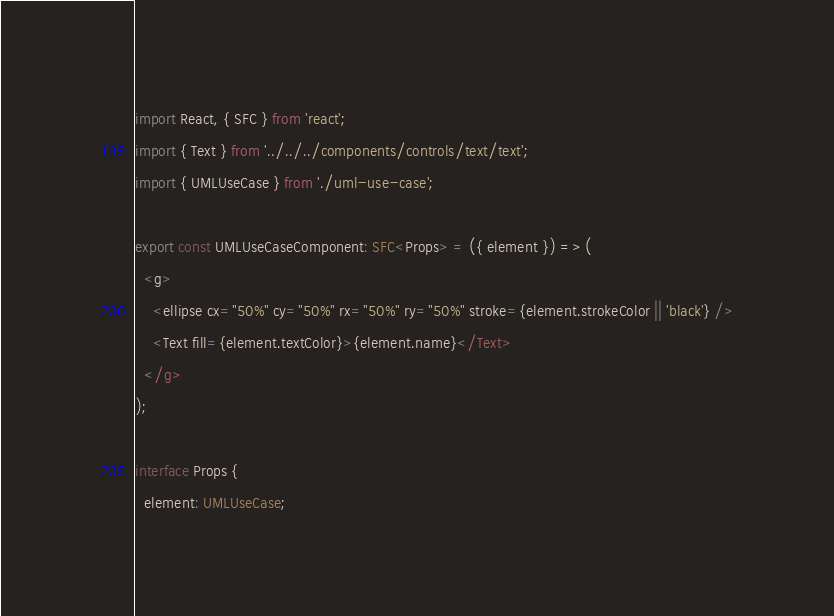Convert code to text. <code><loc_0><loc_0><loc_500><loc_500><_TypeScript_>import React, { SFC } from 'react';
import { Text } from '../../../components/controls/text/text';
import { UMLUseCase } from './uml-use-case';

export const UMLUseCaseComponent: SFC<Props> = ({ element }) => (
  <g>
    <ellipse cx="50%" cy="50%" rx="50%" ry="50%" stroke={element.strokeColor || 'black'} />
    <Text fill={element.textColor}>{element.name}</Text>
  </g>
);

interface Props {
  element: UMLUseCase;</code> 